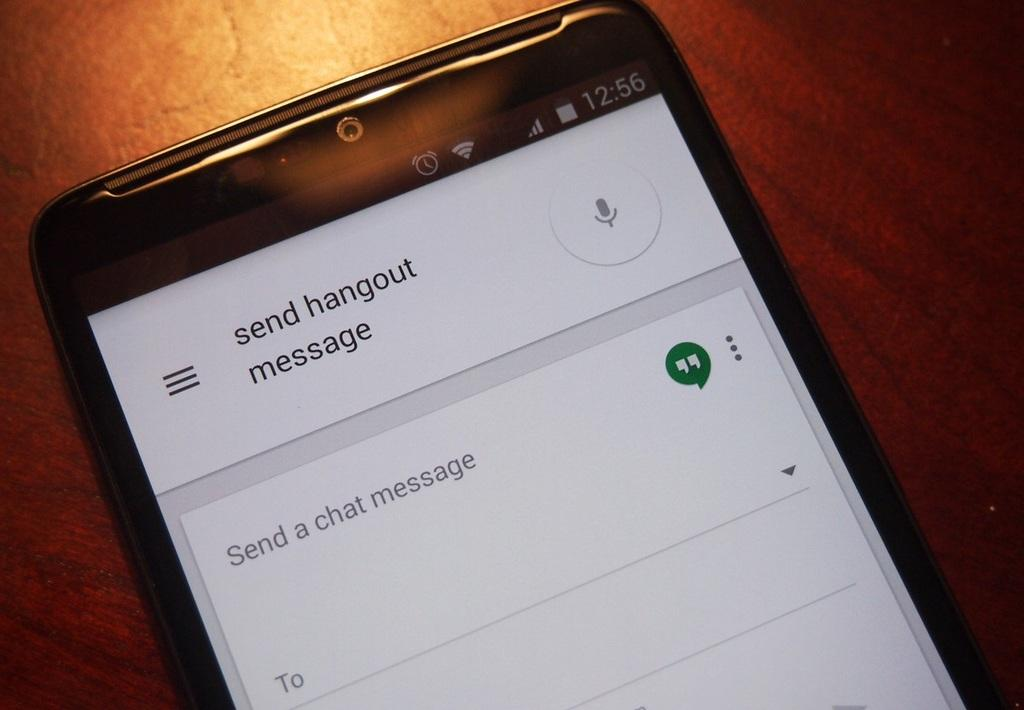<image>
Summarize the visual content of the image. A device showing an option to send a hangout message. 